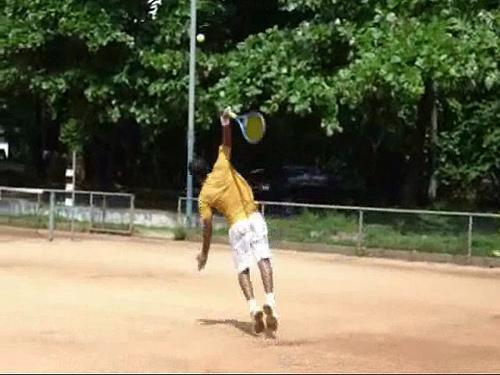The player is using all his energy when preparing to do what with the ball? hit 